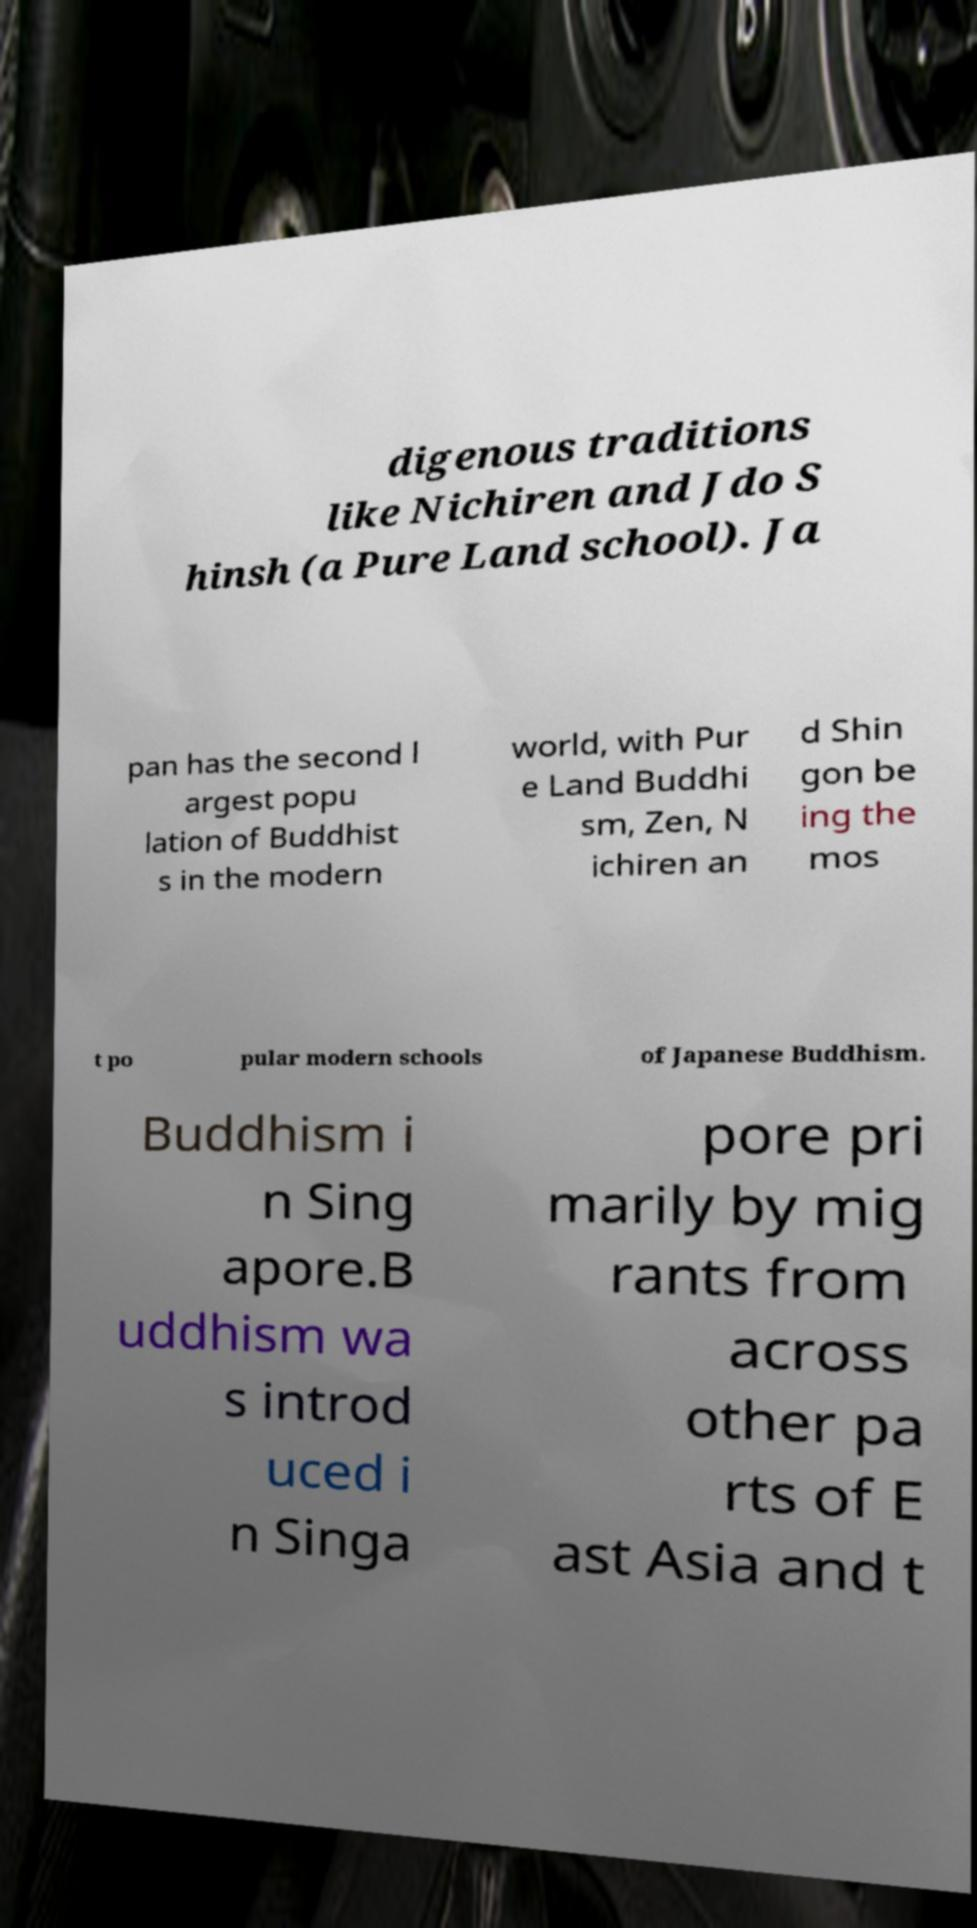Can you read and provide the text displayed in the image?This photo seems to have some interesting text. Can you extract and type it out for me? digenous traditions like Nichiren and Jdo S hinsh (a Pure Land school). Ja pan has the second l argest popu lation of Buddhist s in the modern world, with Pur e Land Buddhi sm, Zen, N ichiren an d Shin gon be ing the mos t po pular modern schools of Japanese Buddhism. Buddhism i n Sing apore.B uddhism wa s introd uced i n Singa pore pri marily by mig rants from across other pa rts of E ast Asia and t 